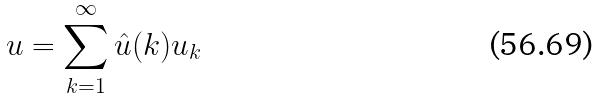Convert formula to latex. <formula><loc_0><loc_0><loc_500><loc_500>u = \sum _ { k = 1 } ^ { \infty } \hat { u } ( k ) u _ { k }</formula> 